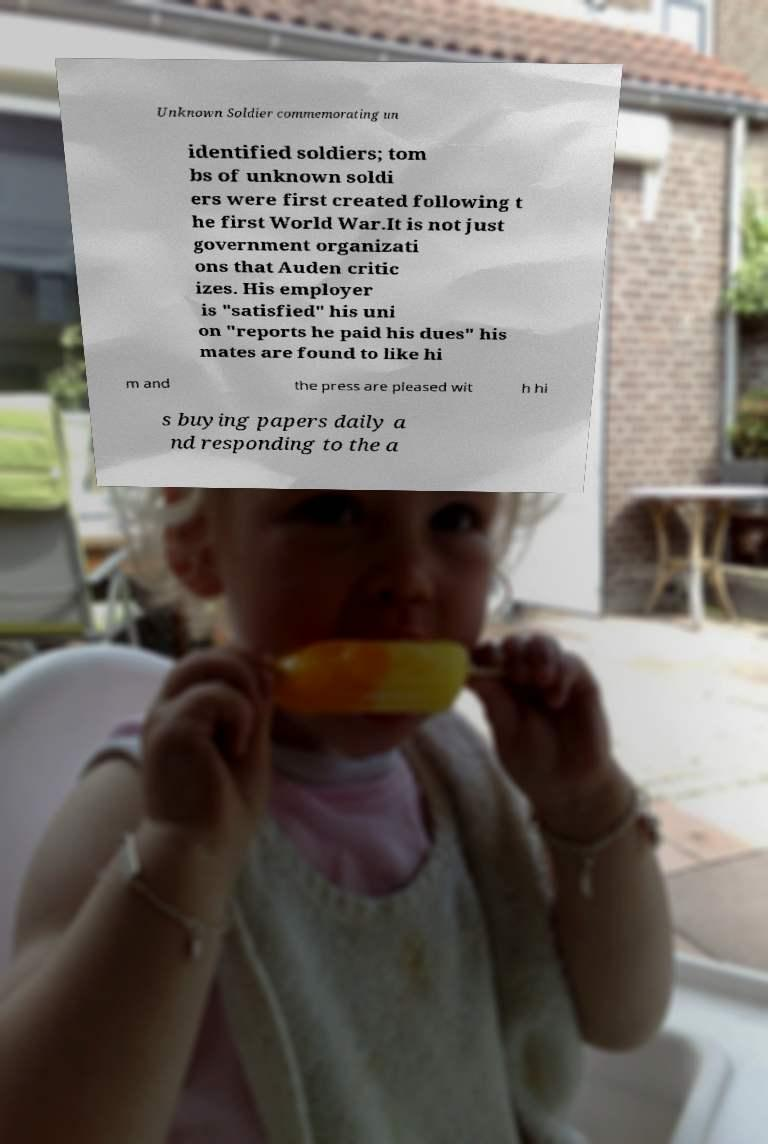There's text embedded in this image that I need extracted. Can you transcribe it verbatim? Unknown Soldier commemorating un identified soldiers; tom bs of unknown soldi ers were first created following t he first World War.It is not just government organizati ons that Auden critic izes. His employer is "satisfied" his uni on "reports he paid his dues" his mates are found to like hi m and the press are pleased wit h hi s buying papers daily a nd responding to the a 